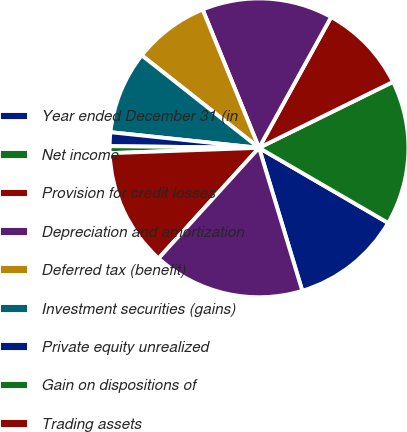Convert chart. <chart><loc_0><loc_0><loc_500><loc_500><pie_chart><fcel>Year ended December 31 (in<fcel>Net income<fcel>Provision for credit losses<fcel>Depreciation and amortization<fcel>Deferred tax (benefit)<fcel>Investment securities (gains)<fcel>Private equity unrealized<fcel>Gain on dispositions of<fcel>Trading assets<fcel>Securities borrowed<nl><fcel>11.94%<fcel>15.67%<fcel>9.7%<fcel>14.18%<fcel>8.21%<fcel>8.96%<fcel>1.49%<fcel>0.75%<fcel>12.69%<fcel>16.42%<nl></chart> 